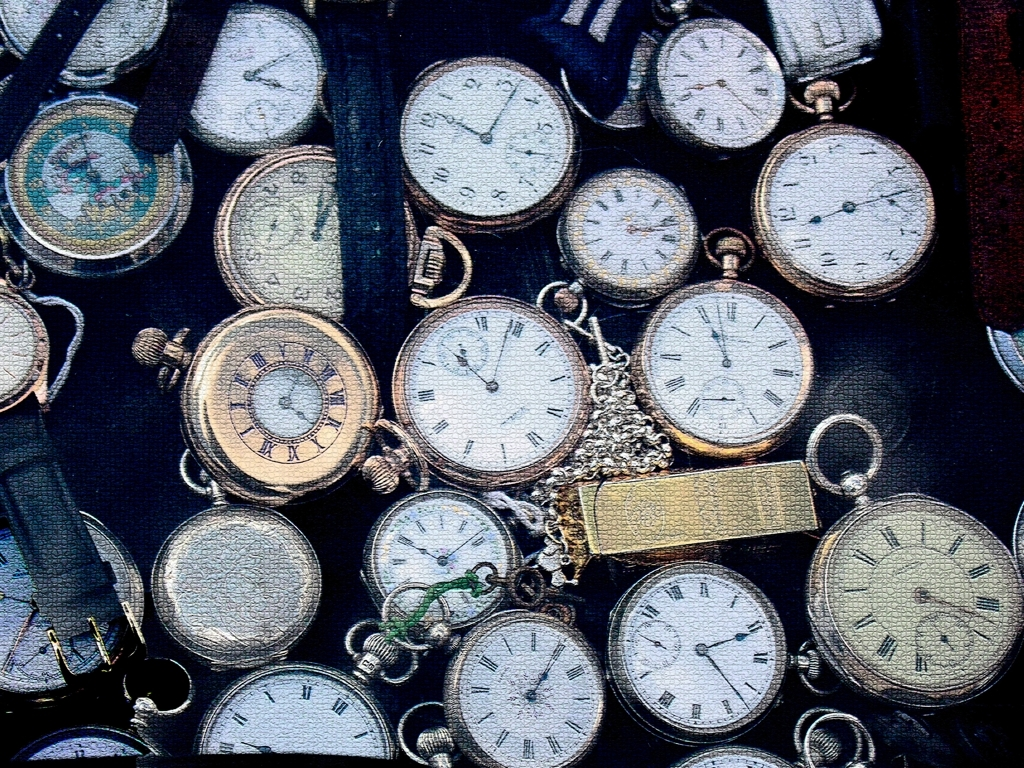Does the image have low clarity?
A. No
B. Yes
Answer with the option's letter from the given choices directly.
 A. 